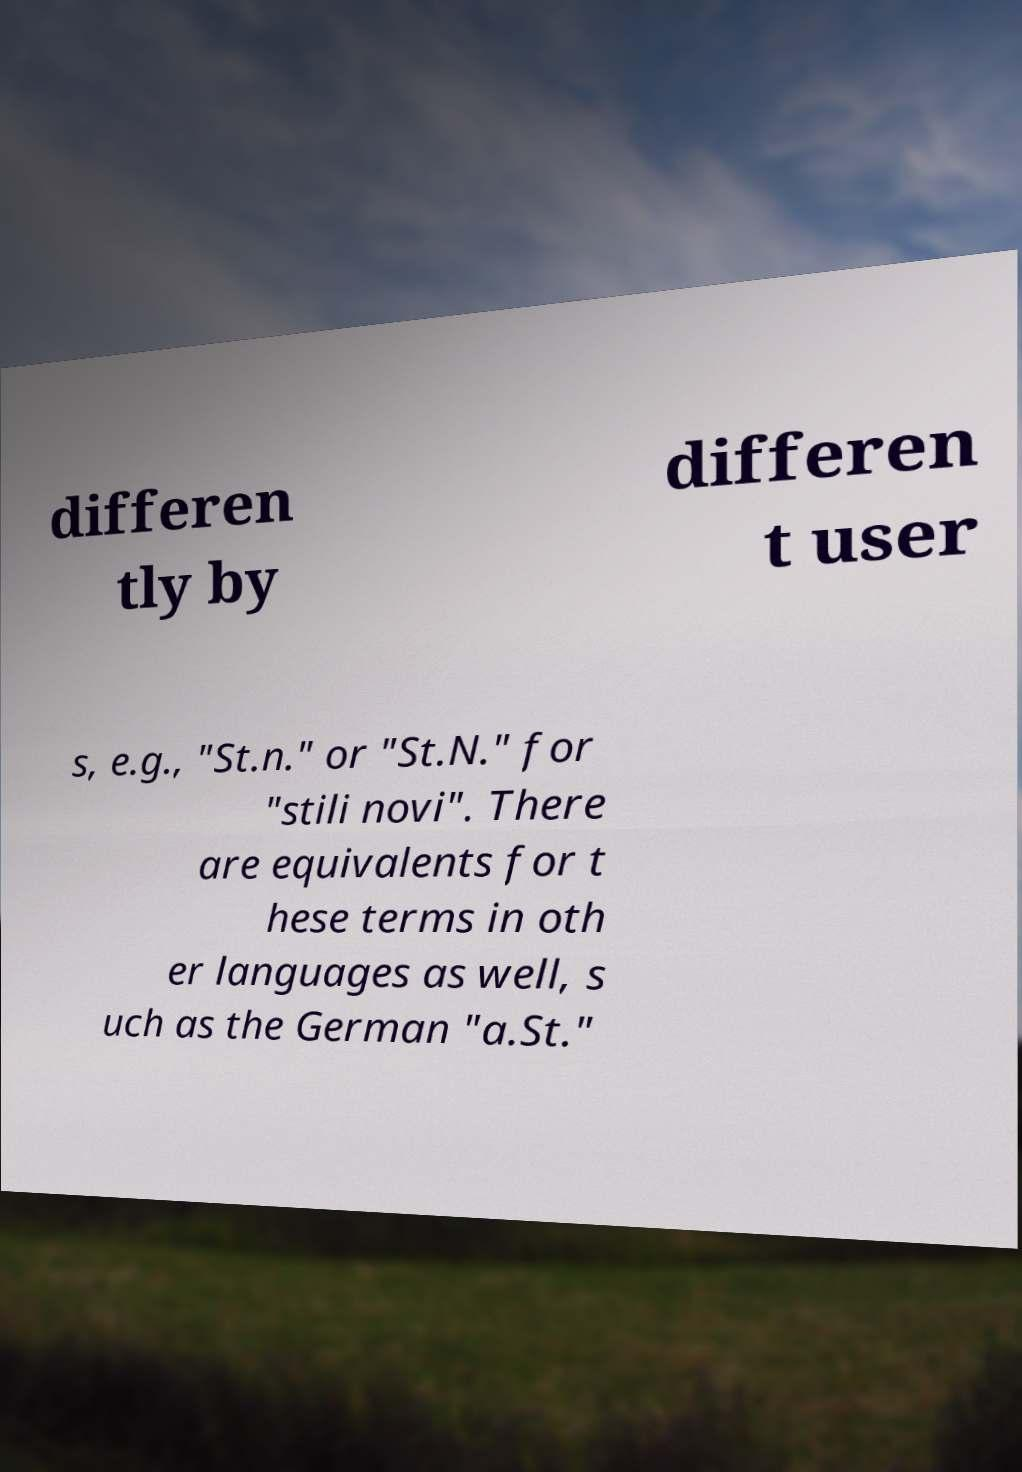Could you assist in decoding the text presented in this image and type it out clearly? differen tly by differen t user s, e.g., "St.n." or "St.N." for "stili novi". There are equivalents for t hese terms in oth er languages as well, s uch as the German "a.St." 